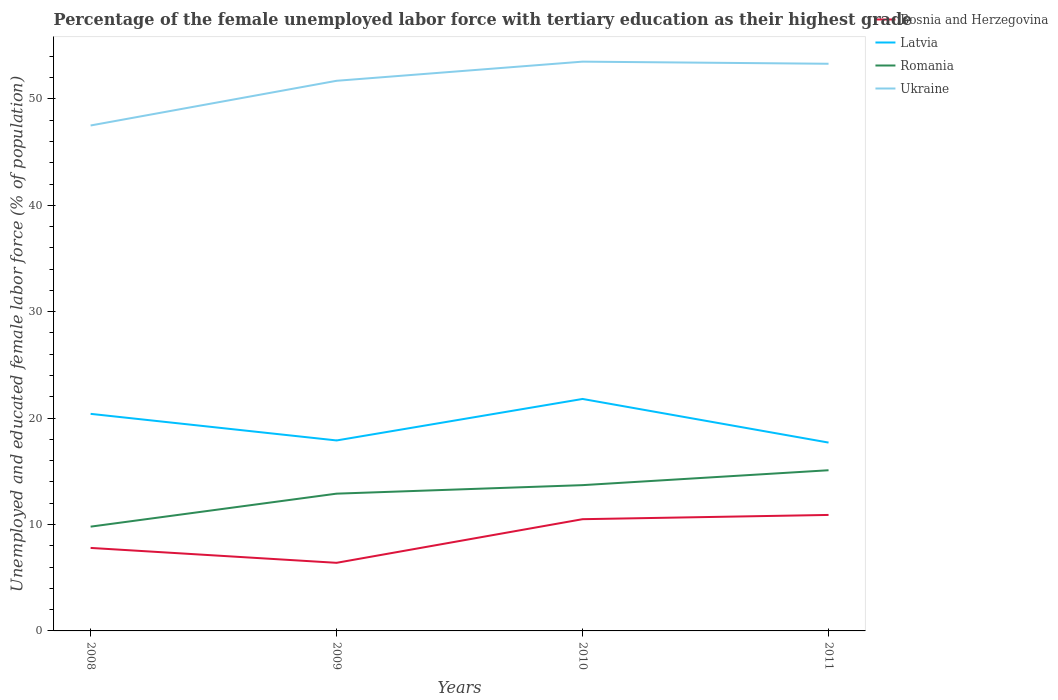How many different coloured lines are there?
Your answer should be very brief. 4. Does the line corresponding to Romania intersect with the line corresponding to Latvia?
Give a very brief answer. No. Across all years, what is the maximum percentage of the unemployed female labor force with tertiary education in Bosnia and Herzegovina?
Provide a succinct answer. 6.4. In which year was the percentage of the unemployed female labor force with tertiary education in Ukraine maximum?
Make the answer very short. 2008. What is the total percentage of the unemployed female labor force with tertiary education in Romania in the graph?
Your response must be concise. -0.8. Is the percentage of the unemployed female labor force with tertiary education in Romania strictly greater than the percentage of the unemployed female labor force with tertiary education in Bosnia and Herzegovina over the years?
Offer a very short reply. No. How many lines are there?
Provide a short and direct response. 4. What is the difference between two consecutive major ticks on the Y-axis?
Provide a succinct answer. 10. Are the values on the major ticks of Y-axis written in scientific E-notation?
Your answer should be very brief. No. Does the graph contain any zero values?
Keep it short and to the point. No. Where does the legend appear in the graph?
Offer a terse response. Top right. How many legend labels are there?
Make the answer very short. 4. How are the legend labels stacked?
Keep it short and to the point. Vertical. What is the title of the graph?
Your response must be concise. Percentage of the female unemployed labor force with tertiary education as their highest grade. What is the label or title of the Y-axis?
Offer a terse response. Unemployed and educated female labor force (% of population). What is the Unemployed and educated female labor force (% of population) in Bosnia and Herzegovina in 2008?
Offer a very short reply. 7.8. What is the Unemployed and educated female labor force (% of population) in Latvia in 2008?
Ensure brevity in your answer.  20.4. What is the Unemployed and educated female labor force (% of population) of Romania in 2008?
Ensure brevity in your answer.  9.8. What is the Unemployed and educated female labor force (% of population) of Ukraine in 2008?
Provide a short and direct response. 47.5. What is the Unemployed and educated female labor force (% of population) in Bosnia and Herzegovina in 2009?
Provide a short and direct response. 6.4. What is the Unemployed and educated female labor force (% of population) of Latvia in 2009?
Your answer should be compact. 17.9. What is the Unemployed and educated female labor force (% of population) in Romania in 2009?
Provide a succinct answer. 12.9. What is the Unemployed and educated female labor force (% of population) of Ukraine in 2009?
Give a very brief answer. 51.7. What is the Unemployed and educated female labor force (% of population) in Bosnia and Herzegovina in 2010?
Give a very brief answer. 10.5. What is the Unemployed and educated female labor force (% of population) in Latvia in 2010?
Keep it short and to the point. 21.8. What is the Unemployed and educated female labor force (% of population) in Romania in 2010?
Provide a short and direct response. 13.7. What is the Unemployed and educated female labor force (% of population) in Ukraine in 2010?
Give a very brief answer. 53.5. What is the Unemployed and educated female labor force (% of population) of Bosnia and Herzegovina in 2011?
Offer a very short reply. 10.9. What is the Unemployed and educated female labor force (% of population) in Latvia in 2011?
Your answer should be compact. 17.7. What is the Unemployed and educated female labor force (% of population) of Romania in 2011?
Offer a terse response. 15.1. What is the Unemployed and educated female labor force (% of population) of Ukraine in 2011?
Make the answer very short. 53.3. Across all years, what is the maximum Unemployed and educated female labor force (% of population) in Bosnia and Herzegovina?
Offer a very short reply. 10.9. Across all years, what is the maximum Unemployed and educated female labor force (% of population) of Latvia?
Your answer should be very brief. 21.8. Across all years, what is the maximum Unemployed and educated female labor force (% of population) of Romania?
Offer a terse response. 15.1. Across all years, what is the maximum Unemployed and educated female labor force (% of population) of Ukraine?
Offer a very short reply. 53.5. Across all years, what is the minimum Unemployed and educated female labor force (% of population) in Bosnia and Herzegovina?
Your answer should be compact. 6.4. Across all years, what is the minimum Unemployed and educated female labor force (% of population) in Latvia?
Offer a terse response. 17.7. Across all years, what is the minimum Unemployed and educated female labor force (% of population) in Romania?
Give a very brief answer. 9.8. Across all years, what is the minimum Unemployed and educated female labor force (% of population) in Ukraine?
Provide a short and direct response. 47.5. What is the total Unemployed and educated female labor force (% of population) in Bosnia and Herzegovina in the graph?
Offer a very short reply. 35.6. What is the total Unemployed and educated female labor force (% of population) in Latvia in the graph?
Your answer should be very brief. 77.8. What is the total Unemployed and educated female labor force (% of population) of Romania in the graph?
Ensure brevity in your answer.  51.5. What is the total Unemployed and educated female labor force (% of population) of Ukraine in the graph?
Make the answer very short. 206. What is the difference between the Unemployed and educated female labor force (% of population) of Ukraine in 2008 and that in 2009?
Offer a terse response. -4.2. What is the difference between the Unemployed and educated female labor force (% of population) of Latvia in 2008 and that in 2010?
Offer a very short reply. -1.4. What is the difference between the Unemployed and educated female labor force (% of population) of Romania in 2008 and that in 2010?
Provide a succinct answer. -3.9. What is the difference between the Unemployed and educated female labor force (% of population) of Bosnia and Herzegovina in 2008 and that in 2011?
Give a very brief answer. -3.1. What is the difference between the Unemployed and educated female labor force (% of population) in Latvia in 2008 and that in 2011?
Offer a very short reply. 2.7. What is the difference between the Unemployed and educated female labor force (% of population) in Ukraine in 2008 and that in 2011?
Offer a very short reply. -5.8. What is the difference between the Unemployed and educated female labor force (% of population) of Latvia in 2009 and that in 2010?
Keep it short and to the point. -3.9. What is the difference between the Unemployed and educated female labor force (% of population) in Romania in 2009 and that in 2010?
Ensure brevity in your answer.  -0.8. What is the difference between the Unemployed and educated female labor force (% of population) of Bosnia and Herzegovina in 2009 and that in 2011?
Give a very brief answer. -4.5. What is the difference between the Unemployed and educated female labor force (% of population) of Romania in 2009 and that in 2011?
Your answer should be very brief. -2.2. What is the difference between the Unemployed and educated female labor force (% of population) in Ukraine in 2009 and that in 2011?
Your answer should be compact. -1.6. What is the difference between the Unemployed and educated female labor force (% of population) in Romania in 2010 and that in 2011?
Offer a terse response. -1.4. What is the difference between the Unemployed and educated female labor force (% of population) in Ukraine in 2010 and that in 2011?
Your response must be concise. 0.2. What is the difference between the Unemployed and educated female labor force (% of population) of Bosnia and Herzegovina in 2008 and the Unemployed and educated female labor force (% of population) of Latvia in 2009?
Your response must be concise. -10.1. What is the difference between the Unemployed and educated female labor force (% of population) in Bosnia and Herzegovina in 2008 and the Unemployed and educated female labor force (% of population) in Ukraine in 2009?
Your response must be concise. -43.9. What is the difference between the Unemployed and educated female labor force (% of population) in Latvia in 2008 and the Unemployed and educated female labor force (% of population) in Romania in 2009?
Your answer should be very brief. 7.5. What is the difference between the Unemployed and educated female labor force (% of population) of Latvia in 2008 and the Unemployed and educated female labor force (% of population) of Ukraine in 2009?
Your answer should be very brief. -31.3. What is the difference between the Unemployed and educated female labor force (% of population) in Romania in 2008 and the Unemployed and educated female labor force (% of population) in Ukraine in 2009?
Offer a very short reply. -41.9. What is the difference between the Unemployed and educated female labor force (% of population) of Bosnia and Herzegovina in 2008 and the Unemployed and educated female labor force (% of population) of Latvia in 2010?
Make the answer very short. -14. What is the difference between the Unemployed and educated female labor force (% of population) in Bosnia and Herzegovina in 2008 and the Unemployed and educated female labor force (% of population) in Romania in 2010?
Keep it short and to the point. -5.9. What is the difference between the Unemployed and educated female labor force (% of population) in Bosnia and Herzegovina in 2008 and the Unemployed and educated female labor force (% of population) in Ukraine in 2010?
Your response must be concise. -45.7. What is the difference between the Unemployed and educated female labor force (% of population) of Latvia in 2008 and the Unemployed and educated female labor force (% of population) of Ukraine in 2010?
Ensure brevity in your answer.  -33.1. What is the difference between the Unemployed and educated female labor force (% of population) in Romania in 2008 and the Unemployed and educated female labor force (% of population) in Ukraine in 2010?
Provide a short and direct response. -43.7. What is the difference between the Unemployed and educated female labor force (% of population) in Bosnia and Herzegovina in 2008 and the Unemployed and educated female labor force (% of population) in Ukraine in 2011?
Provide a succinct answer. -45.5. What is the difference between the Unemployed and educated female labor force (% of population) of Latvia in 2008 and the Unemployed and educated female labor force (% of population) of Romania in 2011?
Give a very brief answer. 5.3. What is the difference between the Unemployed and educated female labor force (% of population) of Latvia in 2008 and the Unemployed and educated female labor force (% of population) of Ukraine in 2011?
Provide a short and direct response. -32.9. What is the difference between the Unemployed and educated female labor force (% of population) in Romania in 2008 and the Unemployed and educated female labor force (% of population) in Ukraine in 2011?
Your answer should be compact. -43.5. What is the difference between the Unemployed and educated female labor force (% of population) in Bosnia and Herzegovina in 2009 and the Unemployed and educated female labor force (% of population) in Latvia in 2010?
Your answer should be very brief. -15.4. What is the difference between the Unemployed and educated female labor force (% of population) in Bosnia and Herzegovina in 2009 and the Unemployed and educated female labor force (% of population) in Romania in 2010?
Your answer should be very brief. -7.3. What is the difference between the Unemployed and educated female labor force (% of population) in Bosnia and Herzegovina in 2009 and the Unemployed and educated female labor force (% of population) in Ukraine in 2010?
Offer a terse response. -47.1. What is the difference between the Unemployed and educated female labor force (% of population) in Latvia in 2009 and the Unemployed and educated female labor force (% of population) in Romania in 2010?
Your response must be concise. 4.2. What is the difference between the Unemployed and educated female labor force (% of population) in Latvia in 2009 and the Unemployed and educated female labor force (% of population) in Ukraine in 2010?
Provide a succinct answer. -35.6. What is the difference between the Unemployed and educated female labor force (% of population) of Romania in 2009 and the Unemployed and educated female labor force (% of population) of Ukraine in 2010?
Offer a terse response. -40.6. What is the difference between the Unemployed and educated female labor force (% of population) of Bosnia and Herzegovina in 2009 and the Unemployed and educated female labor force (% of population) of Latvia in 2011?
Provide a short and direct response. -11.3. What is the difference between the Unemployed and educated female labor force (% of population) in Bosnia and Herzegovina in 2009 and the Unemployed and educated female labor force (% of population) in Ukraine in 2011?
Provide a short and direct response. -46.9. What is the difference between the Unemployed and educated female labor force (% of population) in Latvia in 2009 and the Unemployed and educated female labor force (% of population) in Romania in 2011?
Your answer should be very brief. 2.8. What is the difference between the Unemployed and educated female labor force (% of population) in Latvia in 2009 and the Unemployed and educated female labor force (% of population) in Ukraine in 2011?
Your answer should be very brief. -35.4. What is the difference between the Unemployed and educated female labor force (% of population) of Romania in 2009 and the Unemployed and educated female labor force (% of population) of Ukraine in 2011?
Ensure brevity in your answer.  -40.4. What is the difference between the Unemployed and educated female labor force (% of population) of Bosnia and Herzegovina in 2010 and the Unemployed and educated female labor force (% of population) of Ukraine in 2011?
Your answer should be compact. -42.8. What is the difference between the Unemployed and educated female labor force (% of population) in Latvia in 2010 and the Unemployed and educated female labor force (% of population) in Ukraine in 2011?
Provide a short and direct response. -31.5. What is the difference between the Unemployed and educated female labor force (% of population) of Romania in 2010 and the Unemployed and educated female labor force (% of population) of Ukraine in 2011?
Your answer should be very brief. -39.6. What is the average Unemployed and educated female labor force (% of population) of Bosnia and Herzegovina per year?
Your response must be concise. 8.9. What is the average Unemployed and educated female labor force (% of population) of Latvia per year?
Provide a succinct answer. 19.45. What is the average Unemployed and educated female labor force (% of population) of Romania per year?
Provide a short and direct response. 12.88. What is the average Unemployed and educated female labor force (% of population) in Ukraine per year?
Your answer should be very brief. 51.5. In the year 2008, what is the difference between the Unemployed and educated female labor force (% of population) in Bosnia and Herzegovina and Unemployed and educated female labor force (% of population) in Latvia?
Your response must be concise. -12.6. In the year 2008, what is the difference between the Unemployed and educated female labor force (% of population) of Bosnia and Herzegovina and Unemployed and educated female labor force (% of population) of Romania?
Your answer should be compact. -2. In the year 2008, what is the difference between the Unemployed and educated female labor force (% of population) in Bosnia and Herzegovina and Unemployed and educated female labor force (% of population) in Ukraine?
Provide a succinct answer. -39.7. In the year 2008, what is the difference between the Unemployed and educated female labor force (% of population) of Latvia and Unemployed and educated female labor force (% of population) of Romania?
Provide a succinct answer. 10.6. In the year 2008, what is the difference between the Unemployed and educated female labor force (% of population) in Latvia and Unemployed and educated female labor force (% of population) in Ukraine?
Your answer should be compact. -27.1. In the year 2008, what is the difference between the Unemployed and educated female labor force (% of population) in Romania and Unemployed and educated female labor force (% of population) in Ukraine?
Provide a short and direct response. -37.7. In the year 2009, what is the difference between the Unemployed and educated female labor force (% of population) in Bosnia and Herzegovina and Unemployed and educated female labor force (% of population) in Ukraine?
Your response must be concise. -45.3. In the year 2009, what is the difference between the Unemployed and educated female labor force (% of population) in Latvia and Unemployed and educated female labor force (% of population) in Ukraine?
Provide a short and direct response. -33.8. In the year 2009, what is the difference between the Unemployed and educated female labor force (% of population) of Romania and Unemployed and educated female labor force (% of population) of Ukraine?
Give a very brief answer. -38.8. In the year 2010, what is the difference between the Unemployed and educated female labor force (% of population) in Bosnia and Herzegovina and Unemployed and educated female labor force (% of population) in Latvia?
Provide a short and direct response. -11.3. In the year 2010, what is the difference between the Unemployed and educated female labor force (% of population) in Bosnia and Herzegovina and Unemployed and educated female labor force (% of population) in Romania?
Your response must be concise. -3.2. In the year 2010, what is the difference between the Unemployed and educated female labor force (% of population) in Bosnia and Herzegovina and Unemployed and educated female labor force (% of population) in Ukraine?
Make the answer very short. -43. In the year 2010, what is the difference between the Unemployed and educated female labor force (% of population) of Latvia and Unemployed and educated female labor force (% of population) of Ukraine?
Keep it short and to the point. -31.7. In the year 2010, what is the difference between the Unemployed and educated female labor force (% of population) in Romania and Unemployed and educated female labor force (% of population) in Ukraine?
Give a very brief answer. -39.8. In the year 2011, what is the difference between the Unemployed and educated female labor force (% of population) in Bosnia and Herzegovina and Unemployed and educated female labor force (% of population) in Romania?
Offer a very short reply. -4.2. In the year 2011, what is the difference between the Unemployed and educated female labor force (% of population) of Bosnia and Herzegovina and Unemployed and educated female labor force (% of population) of Ukraine?
Offer a very short reply. -42.4. In the year 2011, what is the difference between the Unemployed and educated female labor force (% of population) in Latvia and Unemployed and educated female labor force (% of population) in Romania?
Provide a short and direct response. 2.6. In the year 2011, what is the difference between the Unemployed and educated female labor force (% of population) of Latvia and Unemployed and educated female labor force (% of population) of Ukraine?
Make the answer very short. -35.6. In the year 2011, what is the difference between the Unemployed and educated female labor force (% of population) in Romania and Unemployed and educated female labor force (% of population) in Ukraine?
Your answer should be very brief. -38.2. What is the ratio of the Unemployed and educated female labor force (% of population) of Bosnia and Herzegovina in 2008 to that in 2009?
Your answer should be very brief. 1.22. What is the ratio of the Unemployed and educated female labor force (% of population) of Latvia in 2008 to that in 2009?
Keep it short and to the point. 1.14. What is the ratio of the Unemployed and educated female labor force (% of population) of Romania in 2008 to that in 2009?
Your response must be concise. 0.76. What is the ratio of the Unemployed and educated female labor force (% of population) of Ukraine in 2008 to that in 2009?
Offer a very short reply. 0.92. What is the ratio of the Unemployed and educated female labor force (% of population) of Bosnia and Herzegovina in 2008 to that in 2010?
Keep it short and to the point. 0.74. What is the ratio of the Unemployed and educated female labor force (% of population) in Latvia in 2008 to that in 2010?
Make the answer very short. 0.94. What is the ratio of the Unemployed and educated female labor force (% of population) of Romania in 2008 to that in 2010?
Make the answer very short. 0.72. What is the ratio of the Unemployed and educated female labor force (% of population) in Ukraine in 2008 to that in 2010?
Your response must be concise. 0.89. What is the ratio of the Unemployed and educated female labor force (% of population) in Bosnia and Herzegovina in 2008 to that in 2011?
Make the answer very short. 0.72. What is the ratio of the Unemployed and educated female labor force (% of population) in Latvia in 2008 to that in 2011?
Give a very brief answer. 1.15. What is the ratio of the Unemployed and educated female labor force (% of population) in Romania in 2008 to that in 2011?
Give a very brief answer. 0.65. What is the ratio of the Unemployed and educated female labor force (% of population) of Ukraine in 2008 to that in 2011?
Keep it short and to the point. 0.89. What is the ratio of the Unemployed and educated female labor force (% of population) in Bosnia and Herzegovina in 2009 to that in 2010?
Your response must be concise. 0.61. What is the ratio of the Unemployed and educated female labor force (% of population) of Latvia in 2009 to that in 2010?
Keep it short and to the point. 0.82. What is the ratio of the Unemployed and educated female labor force (% of population) of Romania in 2009 to that in 2010?
Your answer should be compact. 0.94. What is the ratio of the Unemployed and educated female labor force (% of population) of Ukraine in 2009 to that in 2010?
Ensure brevity in your answer.  0.97. What is the ratio of the Unemployed and educated female labor force (% of population) in Bosnia and Herzegovina in 2009 to that in 2011?
Keep it short and to the point. 0.59. What is the ratio of the Unemployed and educated female labor force (% of population) of Latvia in 2009 to that in 2011?
Offer a very short reply. 1.01. What is the ratio of the Unemployed and educated female labor force (% of population) in Romania in 2009 to that in 2011?
Your answer should be very brief. 0.85. What is the ratio of the Unemployed and educated female labor force (% of population) in Ukraine in 2009 to that in 2011?
Keep it short and to the point. 0.97. What is the ratio of the Unemployed and educated female labor force (% of population) in Bosnia and Herzegovina in 2010 to that in 2011?
Ensure brevity in your answer.  0.96. What is the ratio of the Unemployed and educated female labor force (% of population) of Latvia in 2010 to that in 2011?
Offer a very short reply. 1.23. What is the ratio of the Unemployed and educated female labor force (% of population) in Romania in 2010 to that in 2011?
Offer a terse response. 0.91. What is the ratio of the Unemployed and educated female labor force (% of population) of Ukraine in 2010 to that in 2011?
Your answer should be compact. 1. What is the difference between the highest and the second highest Unemployed and educated female labor force (% of population) in Latvia?
Keep it short and to the point. 1.4. What is the difference between the highest and the second highest Unemployed and educated female labor force (% of population) in Ukraine?
Provide a short and direct response. 0.2. What is the difference between the highest and the lowest Unemployed and educated female labor force (% of population) of Latvia?
Ensure brevity in your answer.  4.1. What is the difference between the highest and the lowest Unemployed and educated female labor force (% of population) of Romania?
Your answer should be very brief. 5.3. 